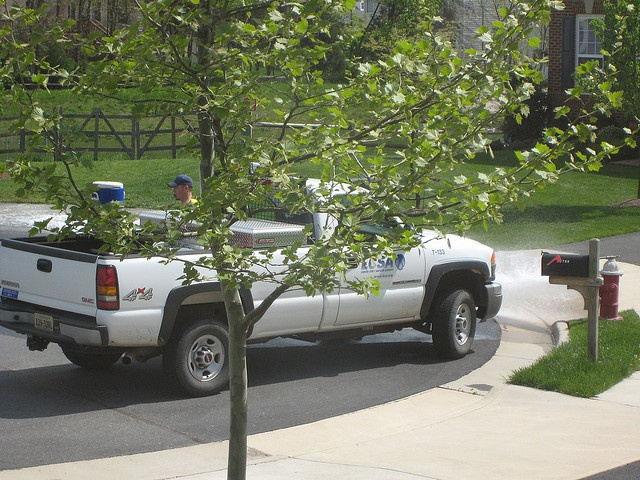Describe the objects in this image and their specific colors. I can see truck in olive, black, gray, darkgray, and lightgray tones, fire hydrant in olive, maroon, darkgray, gray, and lightgray tones, and people in olive, brown, and maroon tones in this image. 